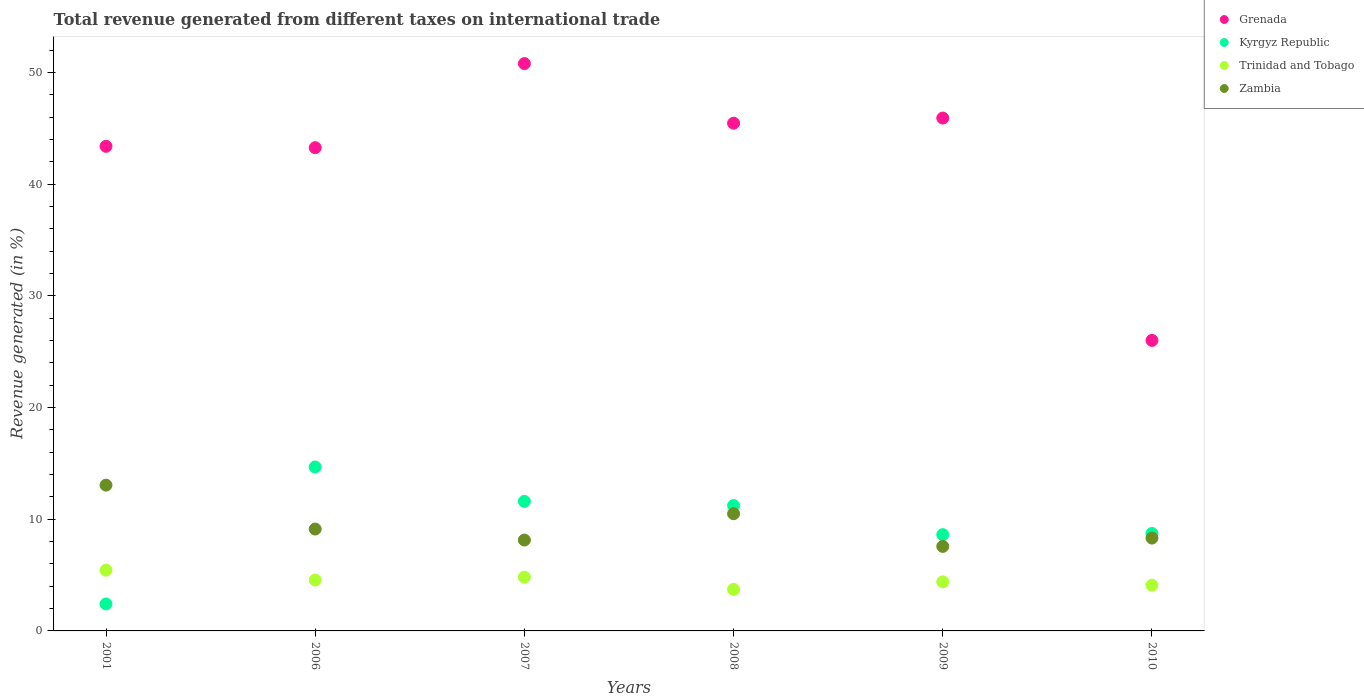How many different coloured dotlines are there?
Offer a terse response. 4. What is the total revenue generated in Trinidad and Tobago in 2006?
Keep it short and to the point. 4.56. Across all years, what is the maximum total revenue generated in Trinidad and Tobago?
Offer a very short reply. 5.44. Across all years, what is the minimum total revenue generated in Trinidad and Tobago?
Your response must be concise. 3.72. In which year was the total revenue generated in Zambia maximum?
Your response must be concise. 2001. What is the total total revenue generated in Trinidad and Tobago in the graph?
Give a very brief answer. 27.02. What is the difference between the total revenue generated in Kyrgyz Republic in 2001 and that in 2008?
Keep it short and to the point. -8.81. What is the difference between the total revenue generated in Trinidad and Tobago in 2006 and the total revenue generated in Zambia in 2001?
Give a very brief answer. -8.5. What is the average total revenue generated in Kyrgyz Republic per year?
Your response must be concise. 9.54. In the year 2010, what is the difference between the total revenue generated in Kyrgyz Republic and total revenue generated in Grenada?
Offer a very short reply. -17.28. In how many years, is the total revenue generated in Kyrgyz Republic greater than 20 %?
Keep it short and to the point. 0. What is the ratio of the total revenue generated in Zambia in 2007 to that in 2008?
Your answer should be very brief. 0.78. Is the total revenue generated in Trinidad and Tobago in 2007 less than that in 2008?
Give a very brief answer. No. Is the difference between the total revenue generated in Kyrgyz Republic in 2007 and 2010 greater than the difference between the total revenue generated in Grenada in 2007 and 2010?
Make the answer very short. No. What is the difference between the highest and the second highest total revenue generated in Trinidad and Tobago?
Make the answer very short. 0.63. What is the difference between the highest and the lowest total revenue generated in Grenada?
Ensure brevity in your answer.  24.78. In how many years, is the total revenue generated in Zambia greater than the average total revenue generated in Zambia taken over all years?
Make the answer very short. 2. Is the sum of the total revenue generated in Grenada in 2007 and 2009 greater than the maximum total revenue generated in Trinidad and Tobago across all years?
Keep it short and to the point. Yes. Is it the case that in every year, the sum of the total revenue generated in Grenada and total revenue generated in Kyrgyz Republic  is greater than the total revenue generated in Trinidad and Tobago?
Ensure brevity in your answer.  Yes. Does the total revenue generated in Zambia monotonically increase over the years?
Give a very brief answer. No. Is the total revenue generated in Kyrgyz Republic strictly greater than the total revenue generated in Zambia over the years?
Provide a short and direct response. No. Does the graph contain any zero values?
Provide a short and direct response. No. Does the graph contain grids?
Keep it short and to the point. No. How many legend labels are there?
Your response must be concise. 4. How are the legend labels stacked?
Offer a very short reply. Vertical. What is the title of the graph?
Offer a very short reply. Total revenue generated from different taxes on international trade. What is the label or title of the X-axis?
Make the answer very short. Years. What is the label or title of the Y-axis?
Give a very brief answer. Revenue generated (in %). What is the Revenue generated (in %) in Grenada in 2001?
Your answer should be compact. 43.38. What is the Revenue generated (in %) in Kyrgyz Republic in 2001?
Provide a succinct answer. 2.41. What is the Revenue generated (in %) of Trinidad and Tobago in 2001?
Offer a terse response. 5.44. What is the Revenue generated (in %) in Zambia in 2001?
Make the answer very short. 13.05. What is the Revenue generated (in %) in Grenada in 2006?
Provide a short and direct response. 43.26. What is the Revenue generated (in %) of Kyrgyz Republic in 2006?
Ensure brevity in your answer.  14.68. What is the Revenue generated (in %) of Trinidad and Tobago in 2006?
Your response must be concise. 4.56. What is the Revenue generated (in %) in Zambia in 2006?
Make the answer very short. 9.12. What is the Revenue generated (in %) of Grenada in 2007?
Your answer should be compact. 50.79. What is the Revenue generated (in %) of Kyrgyz Republic in 2007?
Your answer should be compact. 11.6. What is the Revenue generated (in %) of Trinidad and Tobago in 2007?
Your answer should be compact. 4.81. What is the Revenue generated (in %) of Zambia in 2007?
Offer a very short reply. 8.14. What is the Revenue generated (in %) in Grenada in 2008?
Provide a short and direct response. 45.46. What is the Revenue generated (in %) of Kyrgyz Republic in 2008?
Ensure brevity in your answer.  11.22. What is the Revenue generated (in %) in Trinidad and Tobago in 2008?
Offer a terse response. 3.72. What is the Revenue generated (in %) in Zambia in 2008?
Your answer should be very brief. 10.49. What is the Revenue generated (in %) in Grenada in 2009?
Make the answer very short. 45.92. What is the Revenue generated (in %) in Kyrgyz Republic in 2009?
Your response must be concise. 8.62. What is the Revenue generated (in %) in Trinidad and Tobago in 2009?
Give a very brief answer. 4.4. What is the Revenue generated (in %) of Zambia in 2009?
Offer a terse response. 7.57. What is the Revenue generated (in %) of Grenada in 2010?
Offer a terse response. 26.01. What is the Revenue generated (in %) in Kyrgyz Republic in 2010?
Your response must be concise. 8.73. What is the Revenue generated (in %) in Trinidad and Tobago in 2010?
Make the answer very short. 4.1. What is the Revenue generated (in %) of Zambia in 2010?
Keep it short and to the point. 8.31. Across all years, what is the maximum Revenue generated (in %) in Grenada?
Give a very brief answer. 50.79. Across all years, what is the maximum Revenue generated (in %) of Kyrgyz Republic?
Provide a succinct answer. 14.68. Across all years, what is the maximum Revenue generated (in %) of Trinidad and Tobago?
Give a very brief answer. 5.44. Across all years, what is the maximum Revenue generated (in %) in Zambia?
Keep it short and to the point. 13.05. Across all years, what is the minimum Revenue generated (in %) of Grenada?
Provide a short and direct response. 26.01. Across all years, what is the minimum Revenue generated (in %) in Kyrgyz Republic?
Offer a very short reply. 2.41. Across all years, what is the minimum Revenue generated (in %) of Trinidad and Tobago?
Offer a terse response. 3.72. Across all years, what is the minimum Revenue generated (in %) of Zambia?
Offer a terse response. 7.57. What is the total Revenue generated (in %) of Grenada in the graph?
Provide a short and direct response. 254.82. What is the total Revenue generated (in %) of Kyrgyz Republic in the graph?
Your response must be concise. 57.26. What is the total Revenue generated (in %) in Trinidad and Tobago in the graph?
Offer a terse response. 27.02. What is the total Revenue generated (in %) of Zambia in the graph?
Give a very brief answer. 56.68. What is the difference between the Revenue generated (in %) in Grenada in 2001 and that in 2006?
Your answer should be compact. 0.12. What is the difference between the Revenue generated (in %) of Kyrgyz Republic in 2001 and that in 2006?
Offer a very short reply. -12.26. What is the difference between the Revenue generated (in %) in Trinidad and Tobago in 2001 and that in 2006?
Provide a short and direct response. 0.88. What is the difference between the Revenue generated (in %) of Zambia in 2001 and that in 2006?
Make the answer very short. 3.93. What is the difference between the Revenue generated (in %) of Grenada in 2001 and that in 2007?
Keep it short and to the point. -7.41. What is the difference between the Revenue generated (in %) of Kyrgyz Republic in 2001 and that in 2007?
Make the answer very short. -9.18. What is the difference between the Revenue generated (in %) in Trinidad and Tobago in 2001 and that in 2007?
Offer a very short reply. 0.63. What is the difference between the Revenue generated (in %) of Zambia in 2001 and that in 2007?
Provide a short and direct response. 4.92. What is the difference between the Revenue generated (in %) in Grenada in 2001 and that in 2008?
Make the answer very short. -2.07. What is the difference between the Revenue generated (in %) in Kyrgyz Republic in 2001 and that in 2008?
Your answer should be compact. -8.81. What is the difference between the Revenue generated (in %) of Trinidad and Tobago in 2001 and that in 2008?
Make the answer very short. 1.72. What is the difference between the Revenue generated (in %) in Zambia in 2001 and that in 2008?
Ensure brevity in your answer.  2.56. What is the difference between the Revenue generated (in %) of Grenada in 2001 and that in 2009?
Your response must be concise. -2.53. What is the difference between the Revenue generated (in %) of Kyrgyz Republic in 2001 and that in 2009?
Provide a succinct answer. -6.21. What is the difference between the Revenue generated (in %) of Trinidad and Tobago in 2001 and that in 2009?
Provide a short and direct response. 1.04. What is the difference between the Revenue generated (in %) in Zambia in 2001 and that in 2009?
Your answer should be very brief. 5.48. What is the difference between the Revenue generated (in %) of Grenada in 2001 and that in 2010?
Your answer should be very brief. 17.37. What is the difference between the Revenue generated (in %) of Kyrgyz Republic in 2001 and that in 2010?
Ensure brevity in your answer.  -6.31. What is the difference between the Revenue generated (in %) of Trinidad and Tobago in 2001 and that in 2010?
Keep it short and to the point. 1.34. What is the difference between the Revenue generated (in %) of Zambia in 2001 and that in 2010?
Ensure brevity in your answer.  4.74. What is the difference between the Revenue generated (in %) of Grenada in 2006 and that in 2007?
Provide a succinct answer. -7.53. What is the difference between the Revenue generated (in %) of Kyrgyz Republic in 2006 and that in 2007?
Provide a succinct answer. 3.08. What is the difference between the Revenue generated (in %) in Trinidad and Tobago in 2006 and that in 2007?
Your response must be concise. -0.26. What is the difference between the Revenue generated (in %) of Zambia in 2006 and that in 2007?
Your answer should be very brief. 0.98. What is the difference between the Revenue generated (in %) of Grenada in 2006 and that in 2008?
Provide a succinct answer. -2.19. What is the difference between the Revenue generated (in %) in Kyrgyz Republic in 2006 and that in 2008?
Ensure brevity in your answer.  3.46. What is the difference between the Revenue generated (in %) of Trinidad and Tobago in 2006 and that in 2008?
Give a very brief answer. 0.84. What is the difference between the Revenue generated (in %) in Zambia in 2006 and that in 2008?
Ensure brevity in your answer.  -1.37. What is the difference between the Revenue generated (in %) of Grenada in 2006 and that in 2009?
Your answer should be compact. -2.65. What is the difference between the Revenue generated (in %) in Kyrgyz Republic in 2006 and that in 2009?
Your answer should be very brief. 6.06. What is the difference between the Revenue generated (in %) of Trinidad and Tobago in 2006 and that in 2009?
Keep it short and to the point. 0.16. What is the difference between the Revenue generated (in %) of Zambia in 2006 and that in 2009?
Provide a short and direct response. 1.55. What is the difference between the Revenue generated (in %) in Grenada in 2006 and that in 2010?
Your answer should be compact. 17.26. What is the difference between the Revenue generated (in %) of Kyrgyz Republic in 2006 and that in 2010?
Your response must be concise. 5.95. What is the difference between the Revenue generated (in %) in Trinidad and Tobago in 2006 and that in 2010?
Provide a succinct answer. 0.46. What is the difference between the Revenue generated (in %) of Zambia in 2006 and that in 2010?
Your answer should be compact. 0.81. What is the difference between the Revenue generated (in %) of Grenada in 2007 and that in 2008?
Your response must be concise. 5.34. What is the difference between the Revenue generated (in %) in Kyrgyz Republic in 2007 and that in 2008?
Ensure brevity in your answer.  0.38. What is the difference between the Revenue generated (in %) of Trinidad and Tobago in 2007 and that in 2008?
Keep it short and to the point. 1.09. What is the difference between the Revenue generated (in %) of Zambia in 2007 and that in 2008?
Provide a succinct answer. -2.36. What is the difference between the Revenue generated (in %) of Grenada in 2007 and that in 2009?
Offer a very short reply. 4.88. What is the difference between the Revenue generated (in %) of Kyrgyz Republic in 2007 and that in 2009?
Offer a terse response. 2.98. What is the difference between the Revenue generated (in %) in Trinidad and Tobago in 2007 and that in 2009?
Offer a terse response. 0.42. What is the difference between the Revenue generated (in %) in Zambia in 2007 and that in 2009?
Keep it short and to the point. 0.57. What is the difference between the Revenue generated (in %) in Grenada in 2007 and that in 2010?
Provide a short and direct response. 24.78. What is the difference between the Revenue generated (in %) in Kyrgyz Republic in 2007 and that in 2010?
Your answer should be very brief. 2.87. What is the difference between the Revenue generated (in %) of Trinidad and Tobago in 2007 and that in 2010?
Make the answer very short. 0.72. What is the difference between the Revenue generated (in %) in Zambia in 2007 and that in 2010?
Give a very brief answer. -0.18. What is the difference between the Revenue generated (in %) in Grenada in 2008 and that in 2009?
Your answer should be compact. -0.46. What is the difference between the Revenue generated (in %) in Kyrgyz Republic in 2008 and that in 2009?
Offer a very short reply. 2.6. What is the difference between the Revenue generated (in %) of Trinidad and Tobago in 2008 and that in 2009?
Offer a terse response. -0.68. What is the difference between the Revenue generated (in %) of Zambia in 2008 and that in 2009?
Keep it short and to the point. 2.92. What is the difference between the Revenue generated (in %) in Grenada in 2008 and that in 2010?
Ensure brevity in your answer.  19.45. What is the difference between the Revenue generated (in %) of Kyrgyz Republic in 2008 and that in 2010?
Provide a succinct answer. 2.49. What is the difference between the Revenue generated (in %) of Trinidad and Tobago in 2008 and that in 2010?
Keep it short and to the point. -0.38. What is the difference between the Revenue generated (in %) in Zambia in 2008 and that in 2010?
Keep it short and to the point. 2.18. What is the difference between the Revenue generated (in %) in Grenada in 2009 and that in 2010?
Make the answer very short. 19.91. What is the difference between the Revenue generated (in %) of Kyrgyz Republic in 2009 and that in 2010?
Your answer should be compact. -0.1. What is the difference between the Revenue generated (in %) of Trinidad and Tobago in 2009 and that in 2010?
Provide a succinct answer. 0.3. What is the difference between the Revenue generated (in %) in Zambia in 2009 and that in 2010?
Provide a short and direct response. -0.74. What is the difference between the Revenue generated (in %) of Grenada in 2001 and the Revenue generated (in %) of Kyrgyz Republic in 2006?
Your response must be concise. 28.71. What is the difference between the Revenue generated (in %) of Grenada in 2001 and the Revenue generated (in %) of Trinidad and Tobago in 2006?
Your answer should be compact. 38.83. What is the difference between the Revenue generated (in %) in Grenada in 2001 and the Revenue generated (in %) in Zambia in 2006?
Give a very brief answer. 34.26. What is the difference between the Revenue generated (in %) of Kyrgyz Republic in 2001 and the Revenue generated (in %) of Trinidad and Tobago in 2006?
Your response must be concise. -2.14. What is the difference between the Revenue generated (in %) of Kyrgyz Republic in 2001 and the Revenue generated (in %) of Zambia in 2006?
Your answer should be very brief. -6.71. What is the difference between the Revenue generated (in %) in Trinidad and Tobago in 2001 and the Revenue generated (in %) in Zambia in 2006?
Give a very brief answer. -3.68. What is the difference between the Revenue generated (in %) of Grenada in 2001 and the Revenue generated (in %) of Kyrgyz Republic in 2007?
Keep it short and to the point. 31.79. What is the difference between the Revenue generated (in %) in Grenada in 2001 and the Revenue generated (in %) in Trinidad and Tobago in 2007?
Keep it short and to the point. 38.57. What is the difference between the Revenue generated (in %) in Grenada in 2001 and the Revenue generated (in %) in Zambia in 2007?
Your response must be concise. 35.25. What is the difference between the Revenue generated (in %) of Kyrgyz Republic in 2001 and the Revenue generated (in %) of Trinidad and Tobago in 2007?
Your answer should be very brief. -2.4. What is the difference between the Revenue generated (in %) in Kyrgyz Republic in 2001 and the Revenue generated (in %) in Zambia in 2007?
Your response must be concise. -5.72. What is the difference between the Revenue generated (in %) in Trinidad and Tobago in 2001 and the Revenue generated (in %) in Zambia in 2007?
Ensure brevity in your answer.  -2.7. What is the difference between the Revenue generated (in %) of Grenada in 2001 and the Revenue generated (in %) of Kyrgyz Republic in 2008?
Make the answer very short. 32.16. What is the difference between the Revenue generated (in %) of Grenada in 2001 and the Revenue generated (in %) of Trinidad and Tobago in 2008?
Ensure brevity in your answer.  39.66. What is the difference between the Revenue generated (in %) of Grenada in 2001 and the Revenue generated (in %) of Zambia in 2008?
Offer a terse response. 32.89. What is the difference between the Revenue generated (in %) in Kyrgyz Republic in 2001 and the Revenue generated (in %) in Trinidad and Tobago in 2008?
Your response must be concise. -1.3. What is the difference between the Revenue generated (in %) of Kyrgyz Republic in 2001 and the Revenue generated (in %) of Zambia in 2008?
Offer a very short reply. -8.08. What is the difference between the Revenue generated (in %) in Trinidad and Tobago in 2001 and the Revenue generated (in %) in Zambia in 2008?
Your response must be concise. -5.05. What is the difference between the Revenue generated (in %) in Grenada in 2001 and the Revenue generated (in %) in Kyrgyz Republic in 2009?
Give a very brief answer. 34.76. What is the difference between the Revenue generated (in %) in Grenada in 2001 and the Revenue generated (in %) in Trinidad and Tobago in 2009?
Ensure brevity in your answer.  38.99. What is the difference between the Revenue generated (in %) in Grenada in 2001 and the Revenue generated (in %) in Zambia in 2009?
Make the answer very short. 35.82. What is the difference between the Revenue generated (in %) of Kyrgyz Republic in 2001 and the Revenue generated (in %) of Trinidad and Tobago in 2009?
Provide a succinct answer. -1.98. What is the difference between the Revenue generated (in %) of Kyrgyz Republic in 2001 and the Revenue generated (in %) of Zambia in 2009?
Provide a short and direct response. -5.15. What is the difference between the Revenue generated (in %) of Trinidad and Tobago in 2001 and the Revenue generated (in %) of Zambia in 2009?
Your response must be concise. -2.13. What is the difference between the Revenue generated (in %) of Grenada in 2001 and the Revenue generated (in %) of Kyrgyz Republic in 2010?
Make the answer very short. 34.66. What is the difference between the Revenue generated (in %) of Grenada in 2001 and the Revenue generated (in %) of Trinidad and Tobago in 2010?
Your response must be concise. 39.29. What is the difference between the Revenue generated (in %) of Grenada in 2001 and the Revenue generated (in %) of Zambia in 2010?
Offer a terse response. 35.07. What is the difference between the Revenue generated (in %) in Kyrgyz Republic in 2001 and the Revenue generated (in %) in Trinidad and Tobago in 2010?
Give a very brief answer. -1.68. What is the difference between the Revenue generated (in %) of Kyrgyz Republic in 2001 and the Revenue generated (in %) of Zambia in 2010?
Give a very brief answer. -5.9. What is the difference between the Revenue generated (in %) of Trinidad and Tobago in 2001 and the Revenue generated (in %) of Zambia in 2010?
Provide a short and direct response. -2.87. What is the difference between the Revenue generated (in %) in Grenada in 2006 and the Revenue generated (in %) in Kyrgyz Republic in 2007?
Offer a terse response. 31.67. What is the difference between the Revenue generated (in %) in Grenada in 2006 and the Revenue generated (in %) in Trinidad and Tobago in 2007?
Keep it short and to the point. 38.45. What is the difference between the Revenue generated (in %) of Grenada in 2006 and the Revenue generated (in %) of Zambia in 2007?
Offer a very short reply. 35.13. What is the difference between the Revenue generated (in %) of Kyrgyz Republic in 2006 and the Revenue generated (in %) of Trinidad and Tobago in 2007?
Keep it short and to the point. 9.87. What is the difference between the Revenue generated (in %) of Kyrgyz Republic in 2006 and the Revenue generated (in %) of Zambia in 2007?
Your answer should be very brief. 6.54. What is the difference between the Revenue generated (in %) in Trinidad and Tobago in 2006 and the Revenue generated (in %) in Zambia in 2007?
Your answer should be compact. -3.58. What is the difference between the Revenue generated (in %) in Grenada in 2006 and the Revenue generated (in %) in Kyrgyz Republic in 2008?
Offer a terse response. 32.04. What is the difference between the Revenue generated (in %) of Grenada in 2006 and the Revenue generated (in %) of Trinidad and Tobago in 2008?
Provide a short and direct response. 39.55. What is the difference between the Revenue generated (in %) of Grenada in 2006 and the Revenue generated (in %) of Zambia in 2008?
Your answer should be very brief. 32.77. What is the difference between the Revenue generated (in %) in Kyrgyz Republic in 2006 and the Revenue generated (in %) in Trinidad and Tobago in 2008?
Provide a succinct answer. 10.96. What is the difference between the Revenue generated (in %) in Kyrgyz Republic in 2006 and the Revenue generated (in %) in Zambia in 2008?
Provide a short and direct response. 4.19. What is the difference between the Revenue generated (in %) of Trinidad and Tobago in 2006 and the Revenue generated (in %) of Zambia in 2008?
Your response must be concise. -5.94. What is the difference between the Revenue generated (in %) in Grenada in 2006 and the Revenue generated (in %) in Kyrgyz Republic in 2009?
Keep it short and to the point. 34.64. What is the difference between the Revenue generated (in %) in Grenada in 2006 and the Revenue generated (in %) in Trinidad and Tobago in 2009?
Offer a terse response. 38.87. What is the difference between the Revenue generated (in %) in Grenada in 2006 and the Revenue generated (in %) in Zambia in 2009?
Your response must be concise. 35.7. What is the difference between the Revenue generated (in %) in Kyrgyz Republic in 2006 and the Revenue generated (in %) in Trinidad and Tobago in 2009?
Ensure brevity in your answer.  10.28. What is the difference between the Revenue generated (in %) in Kyrgyz Republic in 2006 and the Revenue generated (in %) in Zambia in 2009?
Make the answer very short. 7.11. What is the difference between the Revenue generated (in %) of Trinidad and Tobago in 2006 and the Revenue generated (in %) of Zambia in 2009?
Provide a short and direct response. -3.01. What is the difference between the Revenue generated (in %) of Grenada in 2006 and the Revenue generated (in %) of Kyrgyz Republic in 2010?
Provide a short and direct response. 34.54. What is the difference between the Revenue generated (in %) of Grenada in 2006 and the Revenue generated (in %) of Trinidad and Tobago in 2010?
Make the answer very short. 39.17. What is the difference between the Revenue generated (in %) of Grenada in 2006 and the Revenue generated (in %) of Zambia in 2010?
Offer a very short reply. 34.95. What is the difference between the Revenue generated (in %) of Kyrgyz Republic in 2006 and the Revenue generated (in %) of Trinidad and Tobago in 2010?
Provide a succinct answer. 10.58. What is the difference between the Revenue generated (in %) of Kyrgyz Republic in 2006 and the Revenue generated (in %) of Zambia in 2010?
Keep it short and to the point. 6.37. What is the difference between the Revenue generated (in %) of Trinidad and Tobago in 2006 and the Revenue generated (in %) of Zambia in 2010?
Provide a short and direct response. -3.76. What is the difference between the Revenue generated (in %) in Grenada in 2007 and the Revenue generated (in %) in Kyrgyz Republic in 2008?
Give a very brief answer. 39.57. What is the difference between the Revenue generated (in %) of Grenada in 2007 and the Revenue generated (in %) of Trinidad and Tobago in 2008?
Provide a short and direct response. 47.07. What is the difference between the Revenue generated (in %) in Grenada in 2007 and the Revenue generated (in %) in Zambia in 2008?
Ensure brevity in your answer.  40.3. What is the difference between the Revenue generated (in %) in Kyrgyz Republic in 2007 and the Revenue generated (in %) in Trinidad and Tobago in 2008?
Provide a succinct answer. 7.88. What is the difference between the Revenue generated (in %) in Kyrgyz Republic in 2007 and the Revenue generated (in %) in Zambia in 2008?
Provide a short and direct response. 1.11. What is the difference between the Revenue generated (in %) in Trinidad and Tobago in 2007 and the Revenue generated (in %) in Zambia in 2008?
Your response must be concise. -5.68. What is the difference between the Revenue generated (in %) of Grenada in 2007 and the Revenue generated (in %) of Kyrgyz Republic in 2009?
Keep it short and to the point. 42.17. What is the difference between the Revenue generated (in %) of Grenada in 2007 and the Revenue generated (in %) of Trinidad and Tobago in 2009?
Your answer should be compact. 46.4. What is the difference between the Revenue generated (in %) of Grenada in 2007 and the Revenue generated (in %) of Zambia in 2009?
Your response must be concise. 43.22. What is the difference between the Revenue generated (in %) of Kyrgyz Republic in 2007 and the Revenue generated (in %) of Trinidad and Tobago in 2009?
Make the answer very short. 7.2. What is the difference between the Revenue generated (in %) in Kyrgyz Republic in 2007 and the Revenue generated (in %) in Zambia in 2009?
Your answer should be very brief. 4.03. What is the difference between the Revenue generated (in %) in Trinidad and Tobago in 2007 and the Revenue generated (in %) in Zambia in 2009?
Your answer should be compact. -2.76. What is the difference between the Revenue generated (in %) of Grenada in 2007 and the Revenue generated (in %) of Kyrgyz Republic in 2010?
Offer a very short reply. 42.07. What is the difference between the Revenue generated (in %) of Grenada in 2007 and the Revenue generated (in %) of Trinidad and Tobago in 2010?
Your answer should be compact. 46.7. What is the difference between the Revenue generated (in %) of Grenada in 2007 and the Revenue generated (in %) of Zambia in 2010?
Keep it short and to the point. 42.48. What is the difference between the Revenue generated (in %) in Kyrgyz Republic in 2007 and the Revenue generated (in %) in Trinidad and Tobago in 2010?
Keep it short and to the point. 7.5. What is the difference between the Revenue generated (in %) in Kyrgyz Republic in 2007 and the Revenue generated (in %) in Zambia in 2010?
Make the answer very short. 3.29. What is the difference between the Revenue generated (in %) of Trinidad and Tobago in 2007 and the Revenue generated (in %) of Zambia in 2010?
Your response must be concise. -3.5. What is the difference between the Revenue generated (in %) in Grenada in 2008 and the Revenue generated (in %) in Kyrgyz Republic in 2009?
Make the answer very short. 36.83. What is the difference between the Revenue generated (in %) in Grenada in 2008 and the Revenue generated (in %) in Trinidad and Tobago in 2009?
Provide a short and direct response. 41.06. What is the difference between the Revenue generated (in %) in Grenada in 2008 and the Revenue generated (in %) in Zambia in 2009?
Offer a terse response. 37.89. What is the difference between the Revenue generated (in %) in Kyrgyz Republic in 2008 and the Revenue generated (in %) in Trinidad and Tobago in 2009?
Ensure brevity in your answer.  6.82. What is the difference between the Revenue generated (in %) of Kyrgyz Republic in 2008 and the Revenue generated (in %) of Zambia in 2009?
Offer a terse response. 3.65. What is the difference between the Revenue generated (in %) of Trinidad and Tobago in 2008 and the Revenue generated (in %) of Zambia in 2009?
Provide a short and direct response. -3.85. What is the difference between the Revenue generated (in %) in Grenada in 2008 and the Revenue generated (in %) in Kyrgyz Republic in 2010?
Make the answer very short. 36.73. What is the difference between the Revenue generated (in %) in Grenada in 2008 and the Revenue generated (in %) in Trinidad and Tobago in 2010?
Offer a terse response. 41.36. What is the difference between the Revenue generated (in %) of Grenada in 2008 and the Revenue generated (in %) of Zambia in 2010?
Provide a succinct answer. 37.14. What is the difference between the Revenue generated (in %) of Kyrgyz Republic in 2008 and the Revenue generated (in %) of Trinidad and Tobago in 2010?
Your answer should be very brief. 7.12. What is the difference between the Revenue generated (in %) in Kyrgyz Republic in 2008 and the Revenue generated (in %) in Zambia in 2010?
Give a very brief answer. 2.91. What is the difference between the Revenue generated (in %) of Trinidad and Tobago in 2008 and the Revenue generated (in %) of Zambia in 2010?
Offer a terse response. -4.59. What is the difference between the Revenue generated (in %) in Grenada in 2009 and the Revenue generated (in %) in Kyrgyz Republic in 2010?
Make the answer very short. 37.19. What is the difference between the Revenue generated (in %) of Grenada in 2009 and the Revenue generated (in %) of Trinidad and Tobago in 2010?
Your answer should be compact. 41.82. What is the difference between the Revenue generated (in %) in Grenada in 2009 and the Revenue generated (in %) in Zambia in 2010?
Your response must be concise. 37.6. What is the difference between the Revenue generated (in %) of Kyrgyz Republic in 2009 and the Revenue generated (in %) of Trinidad and Tobago in 2010?
Offer a very short reply. 4.53. What is the difference between the Revenue generated (in %) of Kyrgyz Republic in 2009 and the Revenue generated (in %) of Zambia in 2010?
Provide a succinct answer. 0.31. What is the difference between the Revenue generated (in %) in Trinidad and Tobago in 2009 and the Revenue generated (in %) in Zambia in 2010?
Your answer should be compact. -3.92. What is the average Revenue generated (in %) of Grenada per year?
Offer a terse response. 42.47. What is the average Revenue generated (in %) in Kyrgyz Republic per year?
Give a very brief answer. 9.54. What is the average Revenue generated (in %) of Trinidad and Tobago per year?
Keep it short and to the point. 4.5. What is the average Revenue generated (in %) in Zambia per year?
Your response must be concise. 9.45. In the year 2001, what is the difference between the Revenue generated (in %) of Grenada and Revenue generated (in %) of Kyrgyz Republic?
Your answer should be compact. 40.97. In the year 2001, what is the difference between the Revenue generated (in %) in Grenada and Revenue generated (in %) in Trinidad and Tobago?
Provide a short and direct response. 37.95. In the year 2001, what is the difference between the Revenue generated (in %) of Grenada and Revenue generated (in %) of Zambia?
Ensure brevity in your answer.  30.33. In the year 2001, what is the difference between the Revenue generated (in %) in Kyrgyz Republic and Revenue generated (in %) in Trinidad and Tobago?
Offer a terse response. -3.02. In the year 2001, what is the difference between the Revenue generated (in %) in Kyrgyz Republic and Revenue generated (in %) in Zambia?
Your answer should be very brief. -10.64. In the year 2001, what is the difference between the Revenue generated (in %) of Trinidad and Tobago and Revenue generated (in %) of Zambia?
Give a very brief answer. -7.61. In the year 2006, what is the difference between the Revenue generated (in %) in Grenada and Revenue generated (in %) in Kyrgyz Republic?
Your response must be concise. 28.59. In the year 2006, what is the difference between the Revenue generated (in %) of Grenada and Revenue generated (in %) of Trinidad and Tobago?
Offer a very short reply. 38.71. In the year 2006, what is the difference between the Revenue generated (in %) of Grenada and Revenue generated (in %) of Zambia?
Your answer should be very brief. 34.14. In the year 2006, what is the difference between the Revenue generated (in %) of Kyrgyz Republic and Revenue generated (in %) of Trinidad and Tobago?
Give a very brief answer. 10.12. In the year 2006, what is the difference between the Revenue generated (in %) of Kyrgyz Republic and Revenue generated (in %) of Zambia?
Make the answer very short. 5.56. In the year 2006, what is the difference between the Revenue generated (in %) in Trinidad and Tobago and Revenue generated (in %) in Zambia?
Provide a succinct answer. -4.57. In the year 2007, what is the difference between the Revenue generated (in %) in Grenada and Revenue generated (in %) in Kyrgyz Republic?
Keep it short and to the point. 39.19. In the year 2007, what is the difference between the Revenue generated (in %) of Grenada and Revenue generated (in %) of Trinidad and Tobago?
Offer a terse response. 45.98. In the year 2007, what is the difference between the Revenue generated (in %) of Grenada and Revenue generated (in %) of Zambia?
Keep it short and to the point. 42.66. In the year 2007, what is the difference between the Revenue generated (in %) of Kyrgyz Republic and Revenue generated (in %) of Trinidad and Tobago?
Give a very brief answer. 6.79. In the year 2007, what is the difference between the Revenue generated (in %) in Kyrgyz Republic and Revenue generated (in %) in Zambia?
Provide a succinct answer. 3.46. In the year 2007, what is the difference between the Revenue generated (in %) in Trinidad and Tobago and Revenue generated (in %) in Zambia?
Provide a short and direct response. -3.32. In the year 2008, what is the difference between the Revenue generated (in %) of Grenada and Revenue generated (in %) of Kyrgyz Republic?
Offer a very short reply. 34.24. In the year 2008, what is the difference between the Revenue generated (in %) in Grenada and Revenue generated (in %) in Trinidad and Tobago?
Provide a short and direct response. 41.74. In the year 2008, what is the difference between the Revenue generated (in %) of Grenada and Revenue generated (in %) of Zambia?
Offer a terse response. 34.96. In the year 2008, what is the difference between the Revenue generated (in %) of Kyrgyz Republic and Revenue generated (in %) of Trinidad and Tobago?
Ensure brevity in your answer.  7.5. In the year 2008, what is the difference between the Revenue generated (in %) of Kyrgyz Republic and Revenue generated (in %) of Zambia?
Your response must be concise. 0.73. In the year 2008, what is the difference between the Revenue generated (in %) of Trinidad and Tobago and Revenue generated (in %) of Zambia?
Your answer should be very brief. -6.77. In the year 2009, what is the difference between the Revenue generated (in %) of Grenada and Revenue generated (in %) of Kyrgyz Republic?
Give a very brief answer. 37.29. In the year 2009, what is the difference between the Revenue generated (in %) in Grenada and Revenue generated (in %) in Trinidad and Tobago?
Provide a succinct answer. 41.52. In the year 2009, what is the difference between the Revenue generated (in %) in Grenada and Revenue generated (in %) in Zambia?
Ensure brevity in your answer.  38.35. In the year 2009, what is the difference between the Revenue generated (in %) in Kyrgyz Republic and Revenue generated (in %) in Trinidad and Tobago?
Provide a succinct answer. 4.23. In the year 2009, what is the difference between the Revenue generated (in %) in Kyrgyz Republic and Revenue generated (in %) in Zambia?
Offer a very short reply. 1.05. In the year 2009, what is the difference between the Revenue generated (in %) of Trinidad and Tobago and Revenue generated (in %) of Zambia?
Your answer should be very brief. -3.17. In the year 2010, what is the difference between the Revenue generated (in %) of Grenada and Revenue generated (in %) of Kyrgyz Republic?
Your answer should be compact. 17.28. In the year 2010, what is the difference between the Revenue generated (in %) in Grenada and Revenue generated (in %) in Trinidad and Tobago?
Provide a succinct answer. 21.91. In the year 2010, what is the difference between the Revenue generated (in %) of Grenada and Revenue generated (in %) of Zambia?
Your answer should be compact. 17.7. In the year 2010, what is the difference between the Revenue generated (in %) of Kyrgyz Republic and Revenue generated (in %) of Trinidad and Tobago?
Ensure brevity in your answer.  4.63. In the year 2010, what is the difference between the Revenue generated (in %) of Kyrgyz Republic and Revenue generated (in %) of Zambia?
Give a very brief answer. 0.41. In the year 2010, what is the difference between the Revenue generated (in %) in Trinidad and Tobago and Revenue generated (in %) in Zambia?
Make the answer very short. -4.22. What is the ratio of the Revenue generated (in %) of Kyrgyz Republic in 2001 to that in 2006?
Give a very brief answer. 0.16. What is the ratio of the Revenue generated (in %) of Trinidad and Tobago in 2001 to that in 2006?
Your response must be concise. 1.19. What is the ratio of the Revenue generated (in %) in Zambia in 2001 to that in 2006?
Your answer should be compact. 1.43. What is the ratio of the Revenue generated (in %) of Grenada in 2001 to that in 2007?
Your answer should be compact. 0.85. What is the ratio of the Revenue generated (in %) in Kyrgyz Republic in 2001 to that in 2007?
Provide a short and direct response. 0.21. What is the ratio of the Revenue generated (in %) of Trinidad and Tobago in 2001 to that in 2007?
Offer a very short reply. 1.13. What is the ratio of the Revenue generated (in %) of Zambia in 2001 to that in 2007?
Make the answer very short. 1.6. What is the ratio of the Revenue generated (in %) of Grenada in 2001 to that in 2008?
Offer a terse response. 0.95. What is the ratio of the Revenue generated (in %) of Kyrgyz Republic in 2001 to that in 2008?
Keep it short and to the point. 0.22. What is the ratio of the Revenue generated (in %) in Trinidad and Tobago in 2001 to that in 2008?
Provide a succinct answer. 1.46. What is the ratio of the Revenue generated (in %) in Zambia in 2001 to that in 2008?
Give a very brief answer. 1.24. What is the ratio of the Revenue generated (in %) of Grenada in 2001 to that in 2009?
Offer a terse response. 0.94. What is the ratio of the Revenue generated (in %) of Kyrgyz Republic in 2001 to that in 2009?
Offer a terse response. 0.28. What is the ratio of the Revenue generated (in %) of Trinidad and Tobago in 2001 to that in 2009?
Ensure brevity in your answer.  1.24. What is the ratio of the Revenue generated (in %) in Zambia in 2001 to that in 2009?
Keep it short and to the point. 1.72. What is the ratio of the Revenue generated (in %) of Grenada in 2001 to that in 2010?
Your answer should be very brief. 1.67. What is the ratio of the Revenue generated (in %) of Kyrgyz Republic in 2001 to that in 2010?
Keep it short and to the point. 0.28. What is the ratio of the Revenue generated (in %) of Trinidad and Tobago in 2001 to that in 2010?
Give a very brief answer. 1.33. What is the ratio of the Revenue generated (in %) in Zambia in 2001 to that in 2010?
Keep it short and to the point. 1.57. What is the ratio of the Revenue generated (in %) of Grenada in 2006 to that in 2007?
Offer a terse response. 0.85. What is the ratio of the Revenue generated (in %) of Kyrgyz Republic in 2006 to that in 2007?
Make the answer very short. 1.27. What is the ratio of the Revenue generated (in %) of Trinidad and Tobago in 2006 to that in 2007?
Provide a short and direct response. 0.95. What is the ratio of the Revenue generated (in %) in Zambia in 2006 to that in 2007?
Your answer should be very brief. 1.12. What is the ratio of the Revenue generated (in %) in Grenada in 2006 to that in 2008?
Your answer should be compact. 0.95. What is the ratio of the Revenue generated (in %) of Kyrgyz Republic in 2006 to that in 2008?
Provide a short and direct response. 1.31. What is the ratio of the Revenue generated (in %) of Trinidad and Tobago in 2006 to that in 2008?
Offer a terse response. 1.22. What is the ratio of the Revenue generated (in %) of Zambia in 2006 to that in 2008?
Your response must be concise. 0.87. What is the ratio of the Revenue generated (in %) in Grenada in 2006 to that in 2009?
Your answer should be very brief. 0.94. What is the ratio of the Revenue generated (in %) in Kyrgyz Republic in 2006 to that in 2009?
Provide a succinct answer. 1.7. What is the ratio of the Revenue generated (in %) in Trinidad and Tobago in 2006 to that in 2009?
Offer a terse response. 1.04. What is the ratio of the Revenue generated (in %) in Zambia in 2006 to that in 2009?
Give a very brief answer. 1.21. What is the ratio of the Revenue generated (in %) in Grenada in 2006 to that in 2010?
Your answer should be compact. 1.66. What is the ratio of the Revenue generated (in %) in Kyrgyz Republic in 2006 to that in 2010?
Keep it short and to the point. 1.68. What is the ratio of the Revenue generated (in %) in Trinidad and Tobago in 2006 to that in 2010?
Offer a very short reply. 1.11. What is the ratio of the Revenue generated (in %) in Zambia in 2006 to that in 2010?
Your response must be concise. 1.1. What is the ratio of the Revenue generated (in %) in Grenada in 2007 to that in 2008?
Provide a succinct answer. 1.12. What is the ratio of the Revenue generated (in %) of Kyrgyz Republic in 2007 to that in 2008?
Your answer should be compact. 1.03. What is the ratio of the Revenue generated (in %) of Trinidad and Tobago in 2007 to that in 2008?
Provide a short and direct response. 1.29. What is the ratio of the Revenue generated (in %) of Zambia in 2007 to that in 2008?
Your answer should be very brief. 0.78. What is the ratio of the Revenue generated (in %) of Grenada in 2007 to that in 2009?
Provide a short and direct response. 1.11. What is the ratio of the Revenue generated (in %) of Kyrgyz Republic in 2007 to that in 2009?
Make the answer very short. 1.35. What is the ratio of the Revenue generated (in %) in Trinidad and Tobago in 2007 to that in 2009?
Provide a short and direct response. 1.09. What is the ratio of the Revenue generated (in %) of Zambia in 2007 to that in 2009?
Provide a succinct answer. 1.07. What is the ratio of the Revenue generated (in %) in Grenada in 2007 to that in 2010?
Offer a very short reply. 1.95. What is the ratio of the Revenue generated (in %) in Kyrgyz Republic in 2007 to that in 2010?
Your answer should be very brief. 1.33. What is the ratio of the Revenue generated (in %) of Trinidad and Tobago in 2007 to that in 2010?
Offer a very short reply. 1.17. What is the ratio of the Revenue generated (in %) in Zambia in 2007 to that in 2010?
Offer a very short reply. 0.98. What is the ratio of the Revenue generated (in %) of Grenada in 2008 to that in 2009?
Your answer should be compact. 0.99. What is the ratio of the Revenue generated (in %) of Kyrgyz Republic in 2008 to that in 2009?
Make the answer very short. 1.3. What is the ratio of the Revenue generated (in %) in Trinidad and Tobago in 2008 to that in 2009?
Your answer should be very brief. 0.85. What is the ratio of the Revenue generated (in %) in Zambia in 2008 to that in 2009?
Ensure brevity in your answer.  1.39. What is the ratio of the Revenue generated (in %) of Grenada in 2008 to that in 2010?
Offer a terse response. 1.75. What is the ratio of the Revenue generated (in %) in Kyrgyz Republic in 2008 to that in 2010?
Your answer should be compact. 1.29. What is the ratio of the Revenue generated (in %) of Trinidad and Tobago in 2008 to that in 2010?
Offer a terse response. 0.91. What is the ratio of the Revenue generated (in %) in Zambia in 2008 to that in 2010?
Offer a very short reply. 1.26. What is the ratio of the Revenue generated (in %) in Grenada in 2009 to that in 2010?
Make the answer very short. 1.77. What is the ratio of the Revenue generated (in %) of Trinidad and Tobago in 2009 to that in 2010?
Offer a very short reply. 1.07. What is the ratio of the Revenue generated (in %) of Zambia in 2009 to that in 2010?
Your response must be concise. 0.91. What is the difference between the highest and the second highest Revenue generated (in %) in Grenada?
Your answer should be very brief. 4.88. What is the difference between the highest and the second highest Revenue generated (in %) of Kyrgyz Republic?
Give a very brief answer. 3.08. What is the difference between the highest and the second highest Revenue generated (in %) in Trinidad and Tobago?
Offer a terse response. 0.63. What is the difference between the highest and the second highest Revenue generated (in %) in Zambia?
Keep it short and to the point. 2.56. What is the difference between the highest and the lowest Revenue generated (in %) of Grenada?
Give a very brief answer. 24.78. What is the difference between the highest and the lowest Revenue generated (in %) of Kyrgyz Republic?
Your response must be concise. 12.26. What is the difference between the highest and the lowest Revenue generated (in %) of Trinidad and Tobago?
Your answer should be compact. 1.72. What is the difference between the highest and the lowest Revenue generated (in %) in Zambia?
Your answer should be very brief. 5.48. 